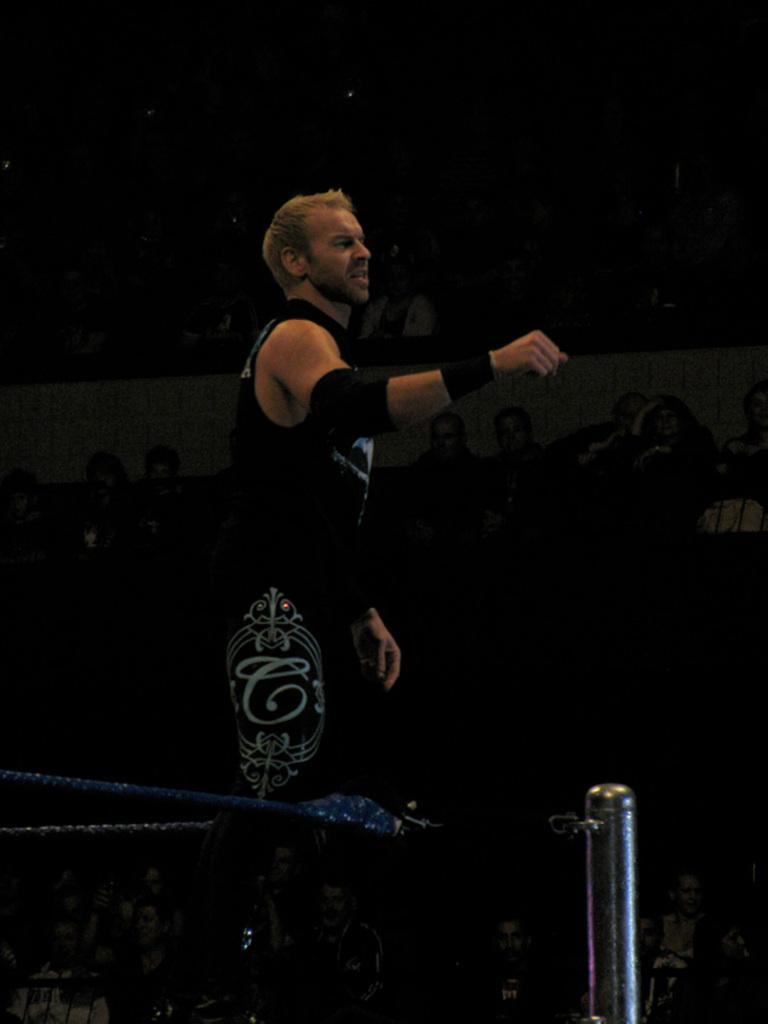Who is the main subject in the foreground of the picture? There is a man in the foreground of the picture. What is the man wearing? The man is wearing a black dress. Where is the man standing? The man is standing in a boxing court. What can be seen in the background of the picture? There are audience members in the background of the picture. What type of appliance is the man using to listen to the audience in the image? There is no appliance present in the image, and the man is not using any device to listen to the audience. 